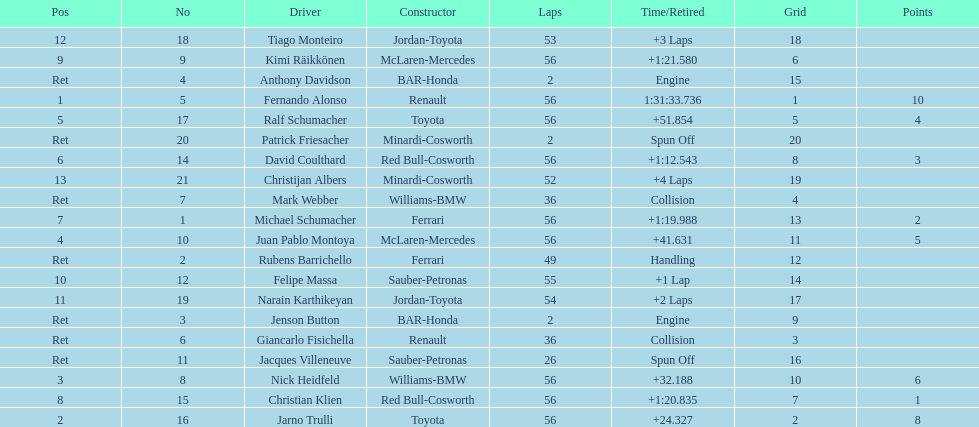Jarno trulli was not french but what nationality? Italian. 